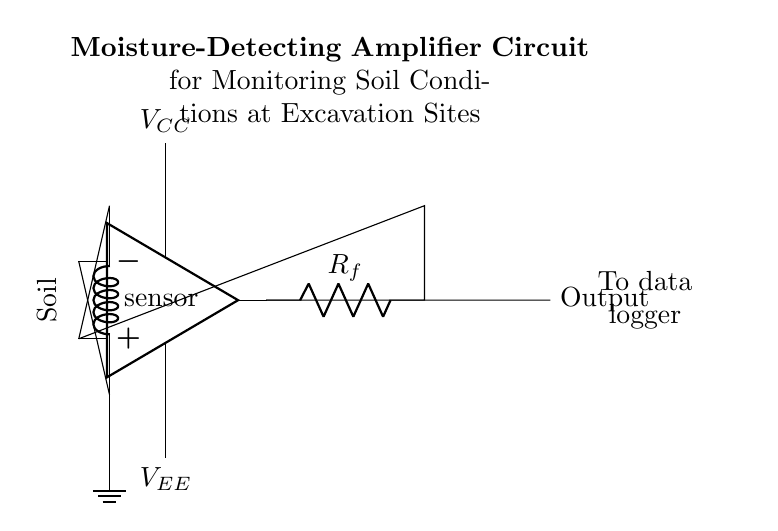What is the component that measures moisture? The diagram shows a sensor labeled "Moisture," which indicates that this component is responsible for detecting moisture levels in the soil.
Answer: Moisture sensor What is the role of the resistor in this circuit? The resistor labeled "R_f" in this circuit is a feedback resistor, which serves to control the gain of the amplifier, impacting how the output signal responds to changes in input.
Answer: Feedback What powers the amplifier? The amplifier is powered by two voltage sources labeled "V_CC" and "V_EE," providing positive and negative supply voltages for its operation.
Answer: V_CC and V_EE What is the purpose of the output in this circuit? The output from the amplifier transmits the amplified signal to a data logger, enabling the collected data to be recorded and analyzed for moisture levels.
Answer: To data logger Why is the soil connected to the negative input of the amplifier? Connecting the soil to the negative input allows the amplifier to compare the moisture input with a reference level, which is essential for proper amplification and signal processing.
Answer: To compare input What are the two main power supplies for the op-amp? The diagram indicates that the op-amp is supplied with two main voltages: a positive voltage (V_CC) and a negative voltage (V_EE), which are necessary for the op-amp's functioning.
Answer: V_CC and V_EE 